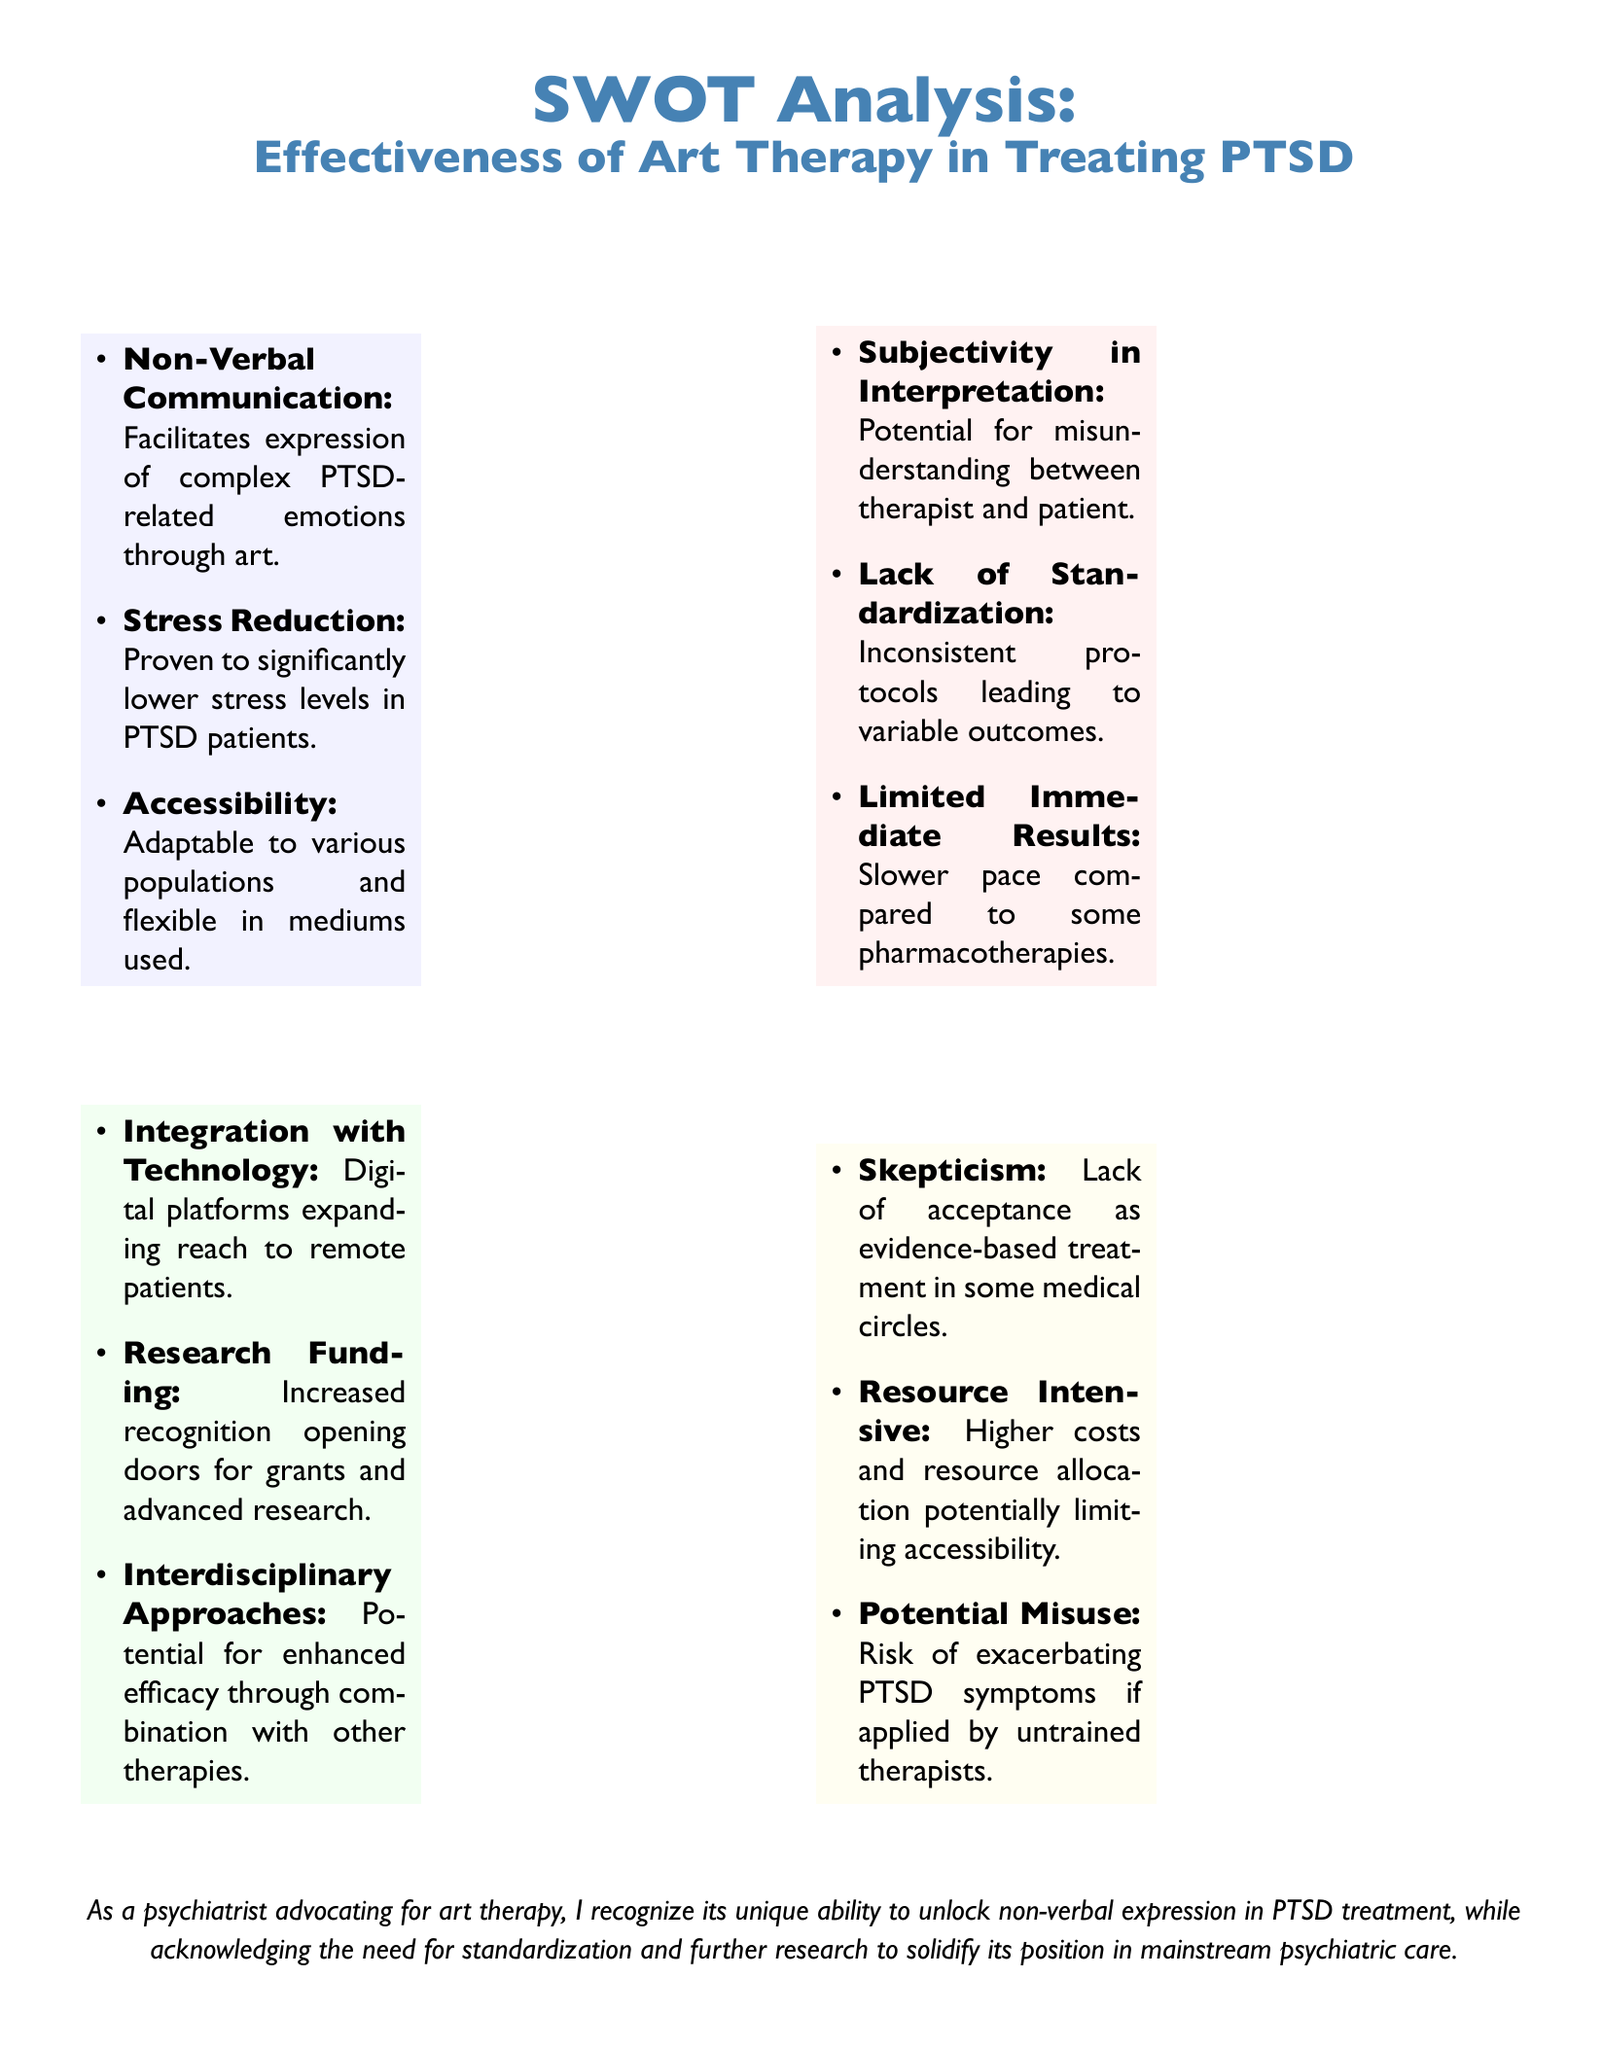What are two strengths of art therapy? The strengths of art therapy include non-verbal communication and stress reduction as stated in the document.
Answer: Non-Verbal Communication, Stress Reduction What is one weakness of art therapy? The document lists subjectivity in interpretation as one of the weaknesses of art therapy.
Answer: Subjectivity in Interpretation What is one opportunity related to art therapy? The document states that integration with technology is a potential opportunity for art therapy.
Answer: Integration with Technology What is one threat to art therapy? According to the document, skepticism about its evidence-based legitimacy is a significant threat to art therapy.
Answer: Skepticism How many strengths are listed in the SWOT analysis? The document specifies three strengths under the Strengths section of the SWOT analysis.
Answer: Three What aspect of PTSD does art therapy focus on primarily? The document highlights that art therapy facilitates the expression of complex PTSD-related emotions through art.
Answer: Expression of complex PTSD-related emotions What does the psychiatrist advocate for? The document indicates that the psychiatrist advocates for art therapy as a form of non-verbal communication in treatment plans.
Answer: Art therapy What is mentioned as a risk of art therapy if applied by untrained therapists? Potential misuse and risk of exacerbating PTSD symptoms are noted in the document as risks of applying art therapy by untrained therapists.
Answer: Risk of exacerbating PTSD symptoms What is the main theme of the SWOT analysis? The document clearly focuses on the effectiveness of art therapy in treating PTSD, detailing various strengths, weaknesses, opportunities, and threats.
Answer: Effectiveness of Art Therapy in Treating PTSD 